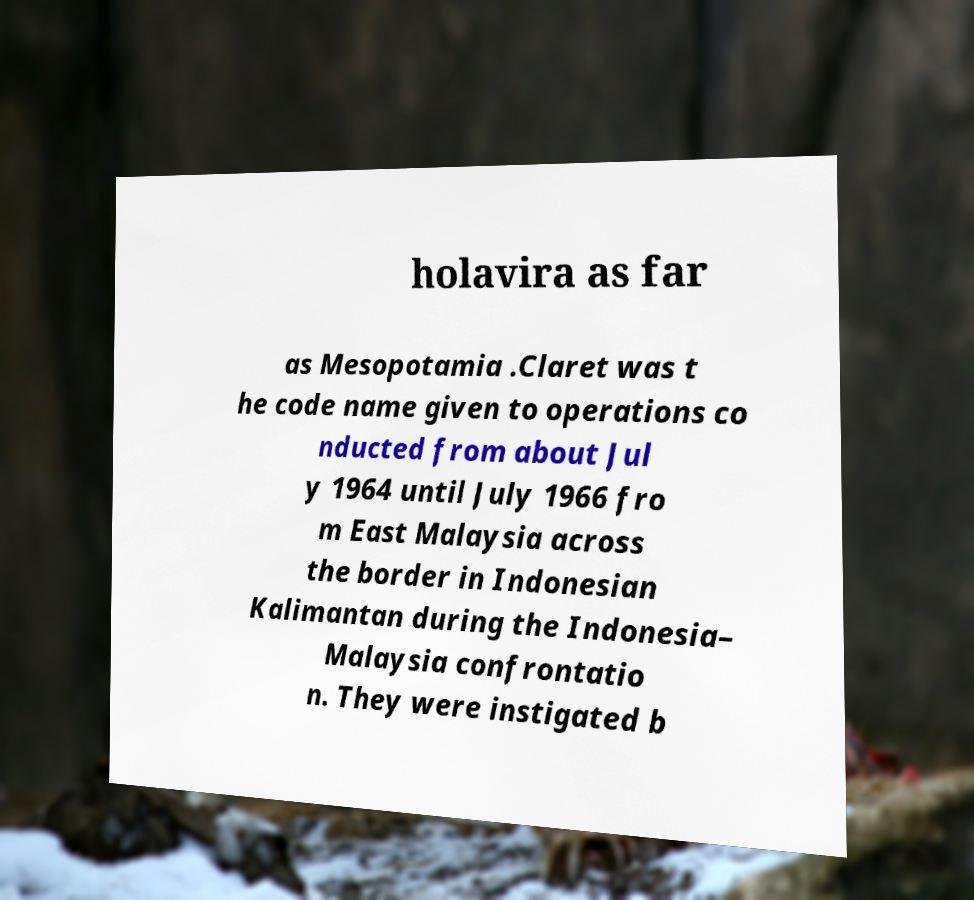I need the written content from this picture converted into text. Can you do that? holavira as far as Mesopotamia .Claret was t he code name given to operations co nducted from about Jul y 1964 until July 1966 fro m East Malaysia across the border in Indonesian Kalimantan during the Indonesia– Malaysia confrontatio n. They were instigated b 